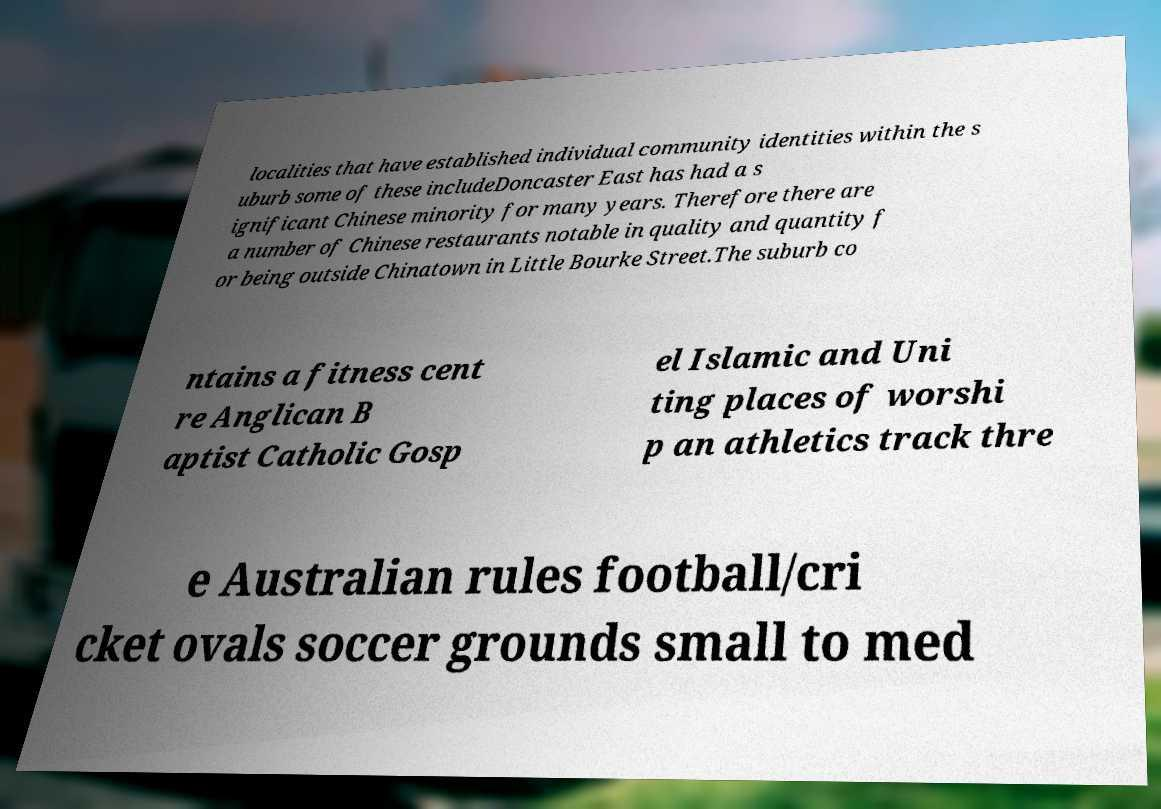Could you assist in decoding the text presented in this image and type it out clearly? localities that have established individual community identities within the s uburb some of these includeDoncaster East has had a s ignificant Chinese minority for many years. Therefore there are a number of Chinese restaurants notable in quality and quantity f or being outside Chinatown in Little Bourke Street.The suburb co ntains a fitness cent re Anglican B aptist Catholic Gosp el Islamic and Uni ting places of worshi p an athletics track thre e Australian rules football/cri cket ovals soccer grounds small to med 